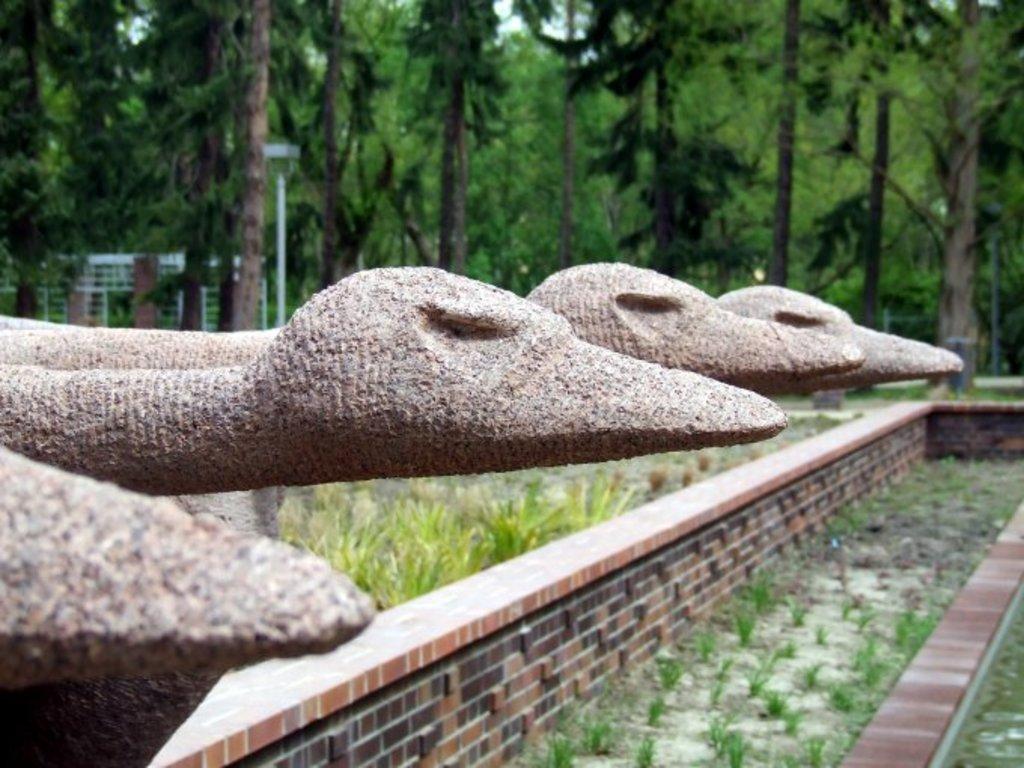Please provide a concise description of this image. In this picture I can see trees and few plants and a pole light and I can see stone carving. 